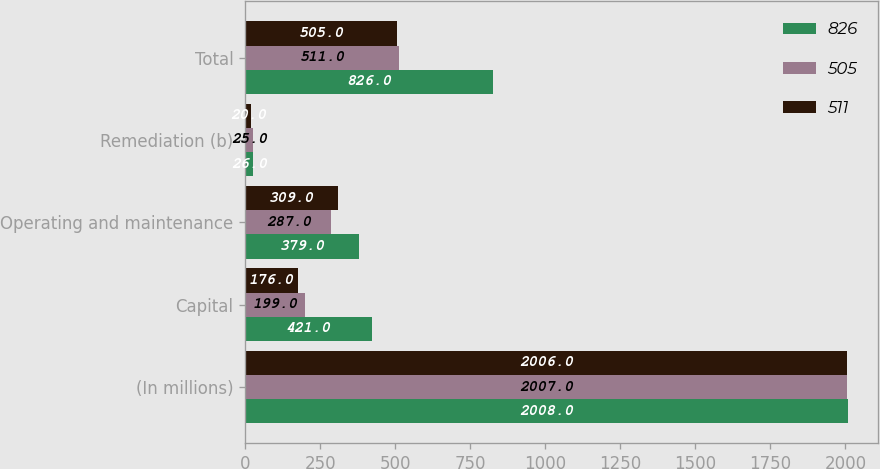Convert chart. <chart><loc_0><loc_0><loc_500><loc_500><stacked_bar_chart><ecel><fcel>(In millions)<fcel>Capital<fcel>Operating and maintenance<fcel>Remediation (b)<fcel>Total<nl><fcel>826<fcel>2008<fcel>421<fcel>379<fcel>26<fcel>826<nl><fcel>505<fcel>2007<fcel>199<fcel>287<fcel>25<fcel>511<nl><fcel>511<fcel>2006<fcel>176<fcel>309<fcel>20<fcel>505<nl></chart> 